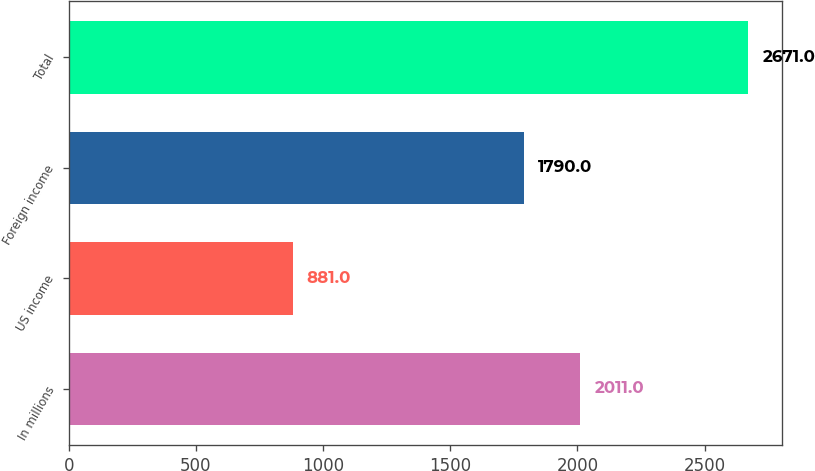Convert chart. <chart><loc_0><loc_0><loc_500><loc_500><bar_chart><fcel>In millions<fcel>US income<fcel>Foreign income<fcel>Total<nl><fcel>2011<fcel>881<fcel>1790<fcel>2671<nl></chart> 